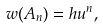Convert formula to latex. <formula><loc_0><loc_0><loc_500><loc_500>w ( A _ { n } ) = h u ^ { n } ,</formula> 